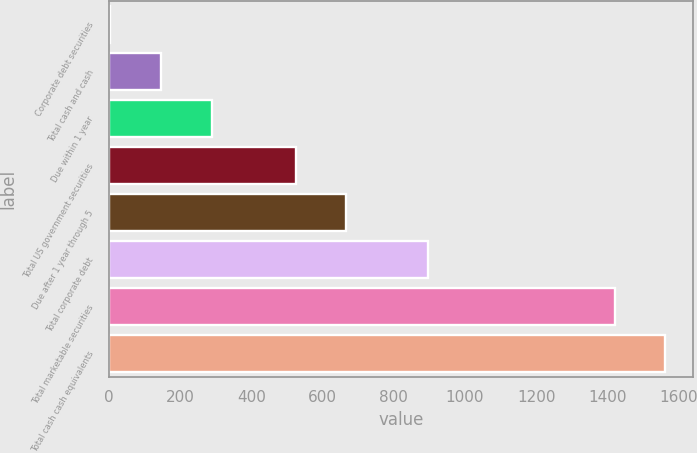Convert chart. <chart><loc_0><loc_0><loc_500><loc_500><bar_chart><fcel>Corporate debt securities<fcel>Total cash and cash<fcel>Due within 1 year<fcel>Total US government securities<fcel>Due after 1 year through 5<fcel>Total corporate debt<fcel>Total marketable securities<fcel>Total cash cash equivalents<nl><fcel>4<fcel>146.1<fcel>288.2<fcel>525<fcel>667.1<fcel>896<fcel>1421<fcel>1563.1<nl></chart> 